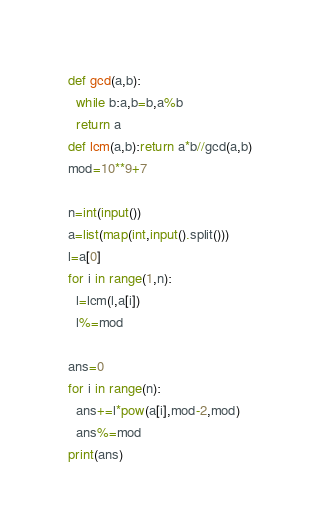Convert code to text. <code><loc_0><loc_0><loc_500><loc_500><_Python_>def gcd(a,b):
  while b:a,b=b,a%b
  return a
def lcm(a,b):return a*b//gcd(a,b)
mod=10**9+7

n=int(input())
a=list(map(int,input().split()))
l=a[0]
for i in range(1,n):
  l=lcm(l,a[i])
  l%=mod

ans=0
for i in range(n):
  ans+=l*pow(a[i],mod-2,mod)
  ans%=mod
print(ans)</code> 